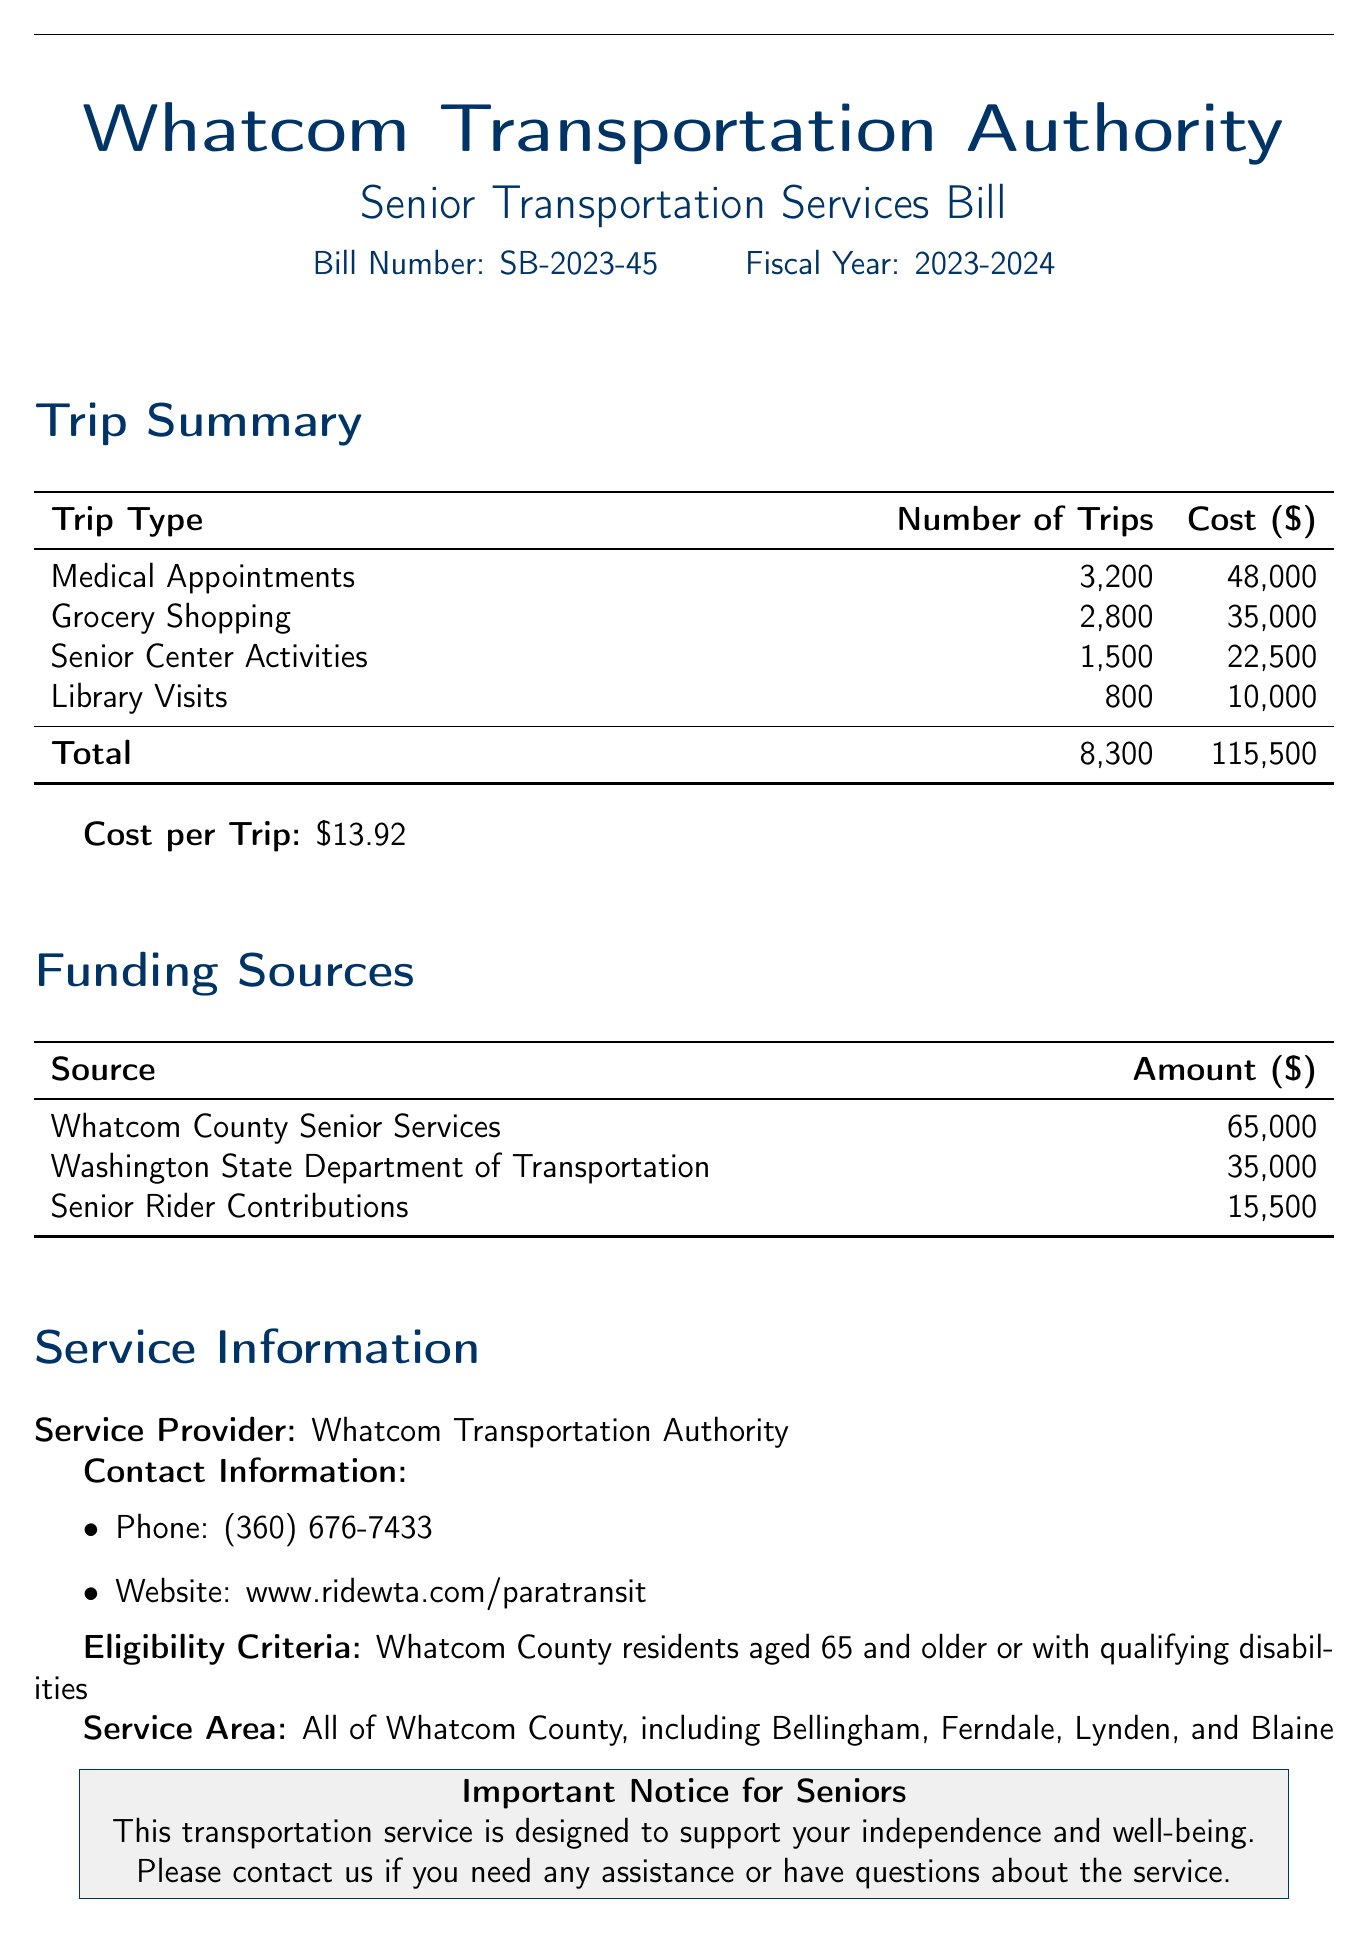What is the bill number? The bill number is explicitly stated at the top of the document under the title section.
Answer: SB-2023-45 What is the total number of trips? The total number of trips is found by adding all the trips for various trip types listed in the Trip Summary section.
Answer: 8,300 What is the cost for medical appointment trips? The cost for medical appointment trips is specified in the Trip Summary table under the Medical Appointments row.
Answer: 48,000 What is the eligibility criteria for the service? The eligibility criteria are defined in the Service Information section of the document.
Answer: Whatcom County residents aged 65 and older or with qualifying disabilities What is the total cost of the senior transportation services? The total cost is summed from the costs of all trip types in the Trip Summary.
Answer: 115,500 How much funding comes from senior rider contributions? The amount from senior rider contributions is provided in the Funding Sources section.
Answer: 15,500 What is the contact phone number for the service? The contact phone number is listed in the Service Information section.
Answer: (360) 676-7433 What is the cost per trip? The cost per trip is calculated from the total cost divided by the total number of trips and is mentioned in the document.
Answer: 13.92 